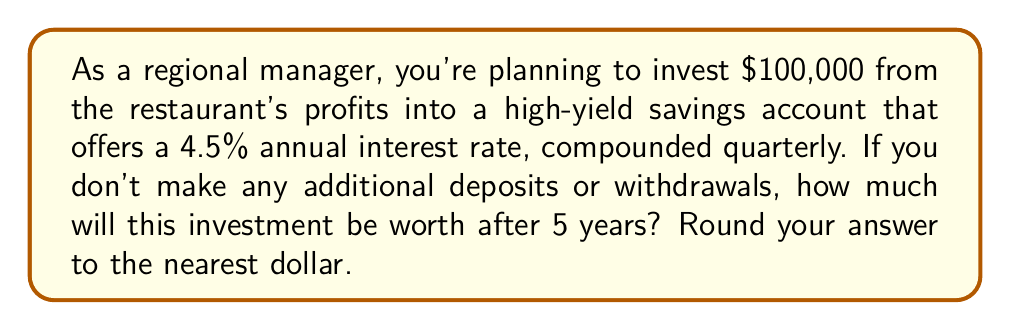Show me your answer to this math problem. To solve this problem, we'll use the compound interest formula:

$$A = P(1 + \frac{r}{n})^{nt}$$

Where:
$A$ = Final amount
$P$ = Principal (initial investment)
$r$ = Annual interest rate (as a decimal)
$n$ = Number of times interest is compounded per year
$t$ = Number of years

Given:
$P = 100,000$
$r = 0.045$ (4.5% expressed as a decimal)
$n = 4$ (compounded quarterly, so 4 times per year)
$t = 5$ years

Let's substitute these values into the formula:

$$A = 100,000(1 + \frac{0.045}{4})^{4 * 5}$$

$$A = 100,000(1 + 0.01125)^{20}$$

$$A = 100,000(1.01125)^{20}$$

Using a calculator or computer to evaluate this expression:

$$A = 100,000 * 1.2497376$$

$$A = 124,973.76$$

Rounding to the nearest dollar:

$$A = 124,974$$
Answer: $124,974 